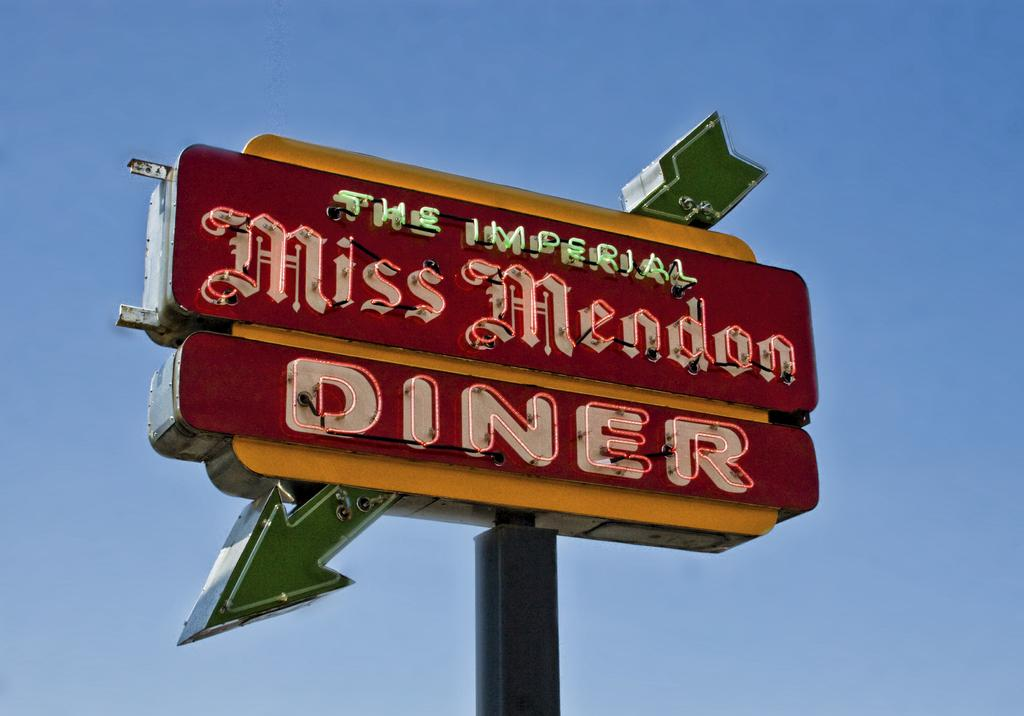<image>
Relay a brief, clear account of the picture shown. The Imperial Miss Mendon Diner restaurant sign with a green arrow pointing down to the left. 